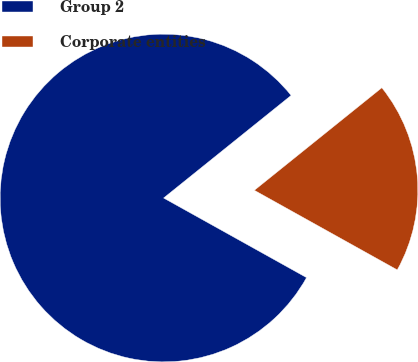<chart> <loc_0><loc_0><loc_500><loc_500><pie_chart><fcel>Group 2<fcel>Corporate entities<nl><fcel>81.16%<fcel>18.84%<nl></chart> 